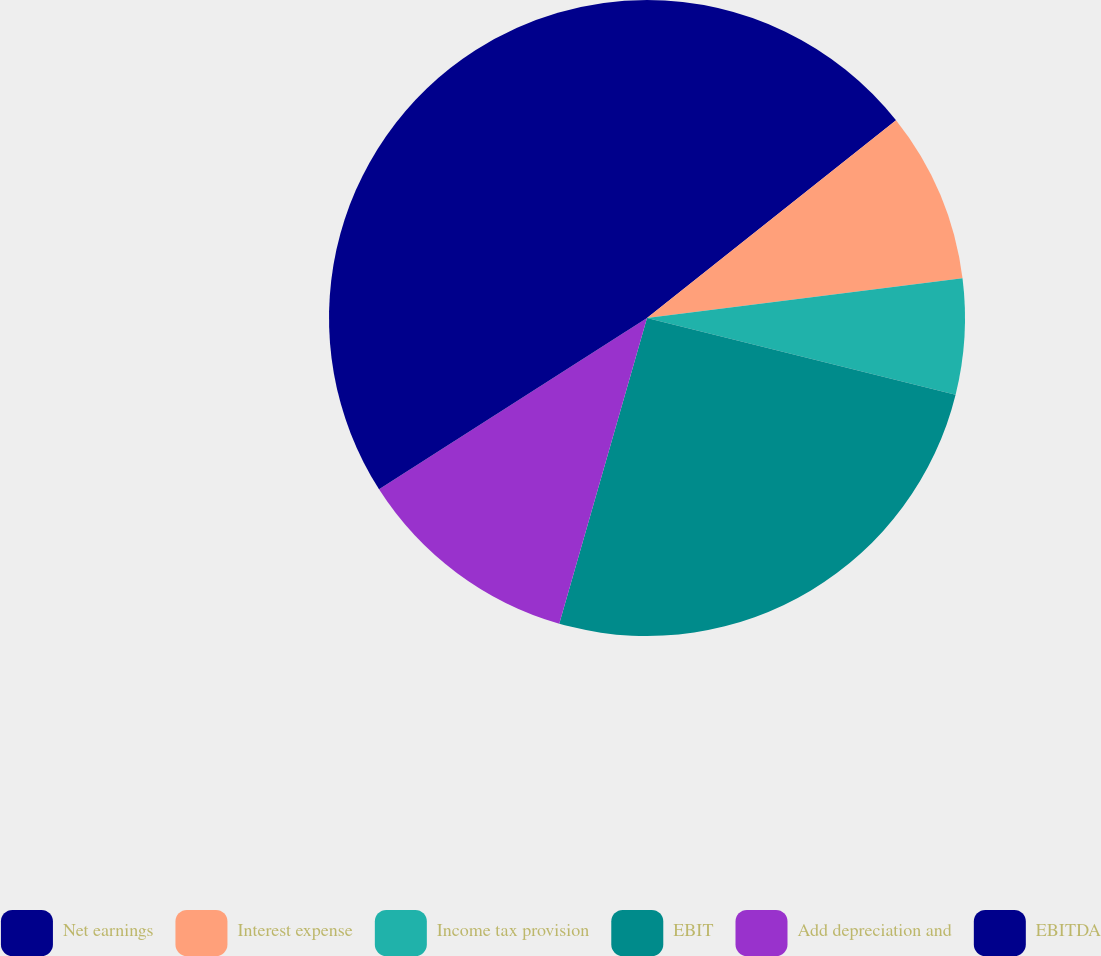<chart> <loc_0><loc_0><loc_500><loc_500><pie_chart><fcel>Net earnings<fcel>Interest expense<fcel>Income tax provision<fcel>EBIT<fcel>Add depreciation and<fcel>EBITDA<nl><fcel>14.32%<fcel>8.69%<fcel>5.87%<fcel>25.57%<fcel>11.5%<fcel>34.05%<nl></chart> 